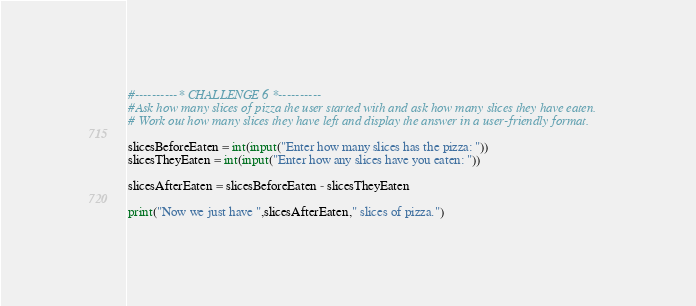Convert code to text. <code><loc_0><loc_0><loc_500><loc_500><_Python_>#----------* CHALLENGE 6 *----------
#Ask how many slices of pizza the user started with and ask how many slices they have eaten. 
# Work out how many slices they have left and display the answer in a user-friendly format.

slicesBeforeEaten = int(input("Enter how many slices has the pizza: "))
slicesTheyEaten = int(input("Enter how any slices have you eaten: "))

slicesAfterEaten = slicesBeforeEaten - slicesTheyEaten

print("Now we just have ",slicesAfterEaten," slices of pizza.")
</code> 